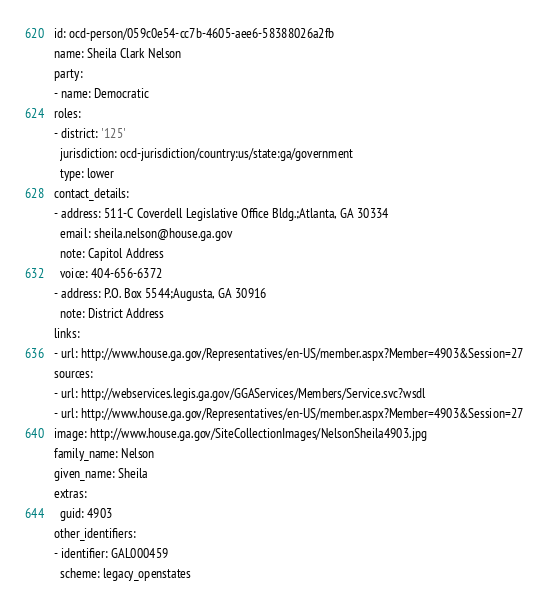Convert code to text. <code><loc_0><loc_0><loc_500><loc_500><_YAML_>id: ocd-person/059c0e54-cc7b-4605-aee6-58388026a2fb
name: Sheila Clark Nelson
party:
- name: Democratic
roles:
- district: '125'
  jurisdiction: ocd-jurisdiction/country:us/state:ga/government
  type: lower
contact_details:
- address: 511-C Coverdell Legislative Office Bldg.;Atlanta, GA 30334
  email: sheila.nelson@house.ga.gov
  note: Capitol Address
  voice: 404-656-6372
- address: P.O. Box 5544;Augusta, GA 30916
  note: District Address
links:
- url: http://www.house.ga.gov/Representatives/en-US/member.aspx?Member=4903&Session=27
sources:
- url: http://webservices.legis.ga.gov/GGAServices/Members/Service.svc?wsdl
- url: http://www.house.ga.gov/Representatives/en-US/member.aspx?Member=4903&Session=27
image: http://www.house.ga.gov/SiteCollectionImages/NelsonSheila4903.jpg
family_name: Nelson
given_name: Sheila
extras:
  guid: 4903
other_identifiers:
- identifier: GAL000459
  scheme: legacy_openstates
</code> 